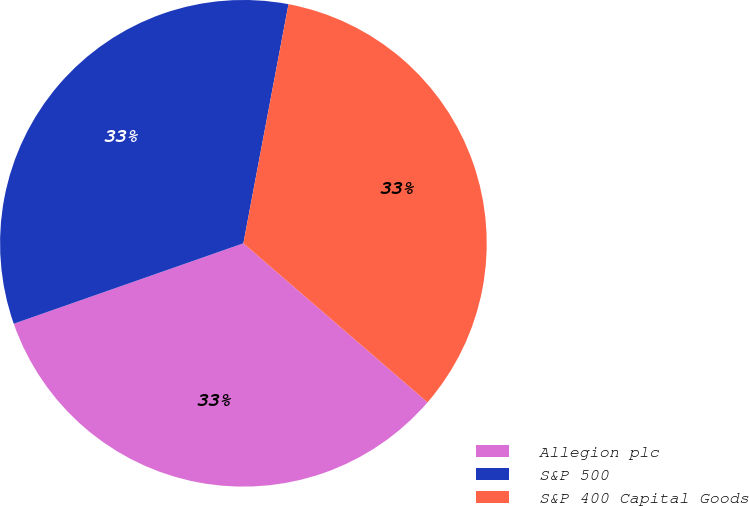<chart> <loc_0><loc_0><loc_500><loc_500><pie_chart><fcel>Allegion plc<fcel>S&P 500<fcel>S&P 400 Capital Goods<nl><fcel>33.3%<fcel>33.33%<fcel>33.37%<nl></chart> 